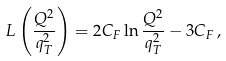Convert formula to latex. <formula><loc_0><loc_0><loc_500><loc_500>L \left ( \frac { Q ^ { 2 } } { q _ { T } ^ { 2 } } \right ) = 2 C _ { F } \ln \frac { Q ^ { 2 } } { q _ { T } ^ { 2 } } - 3 C _ { F } \, ,</formula> 